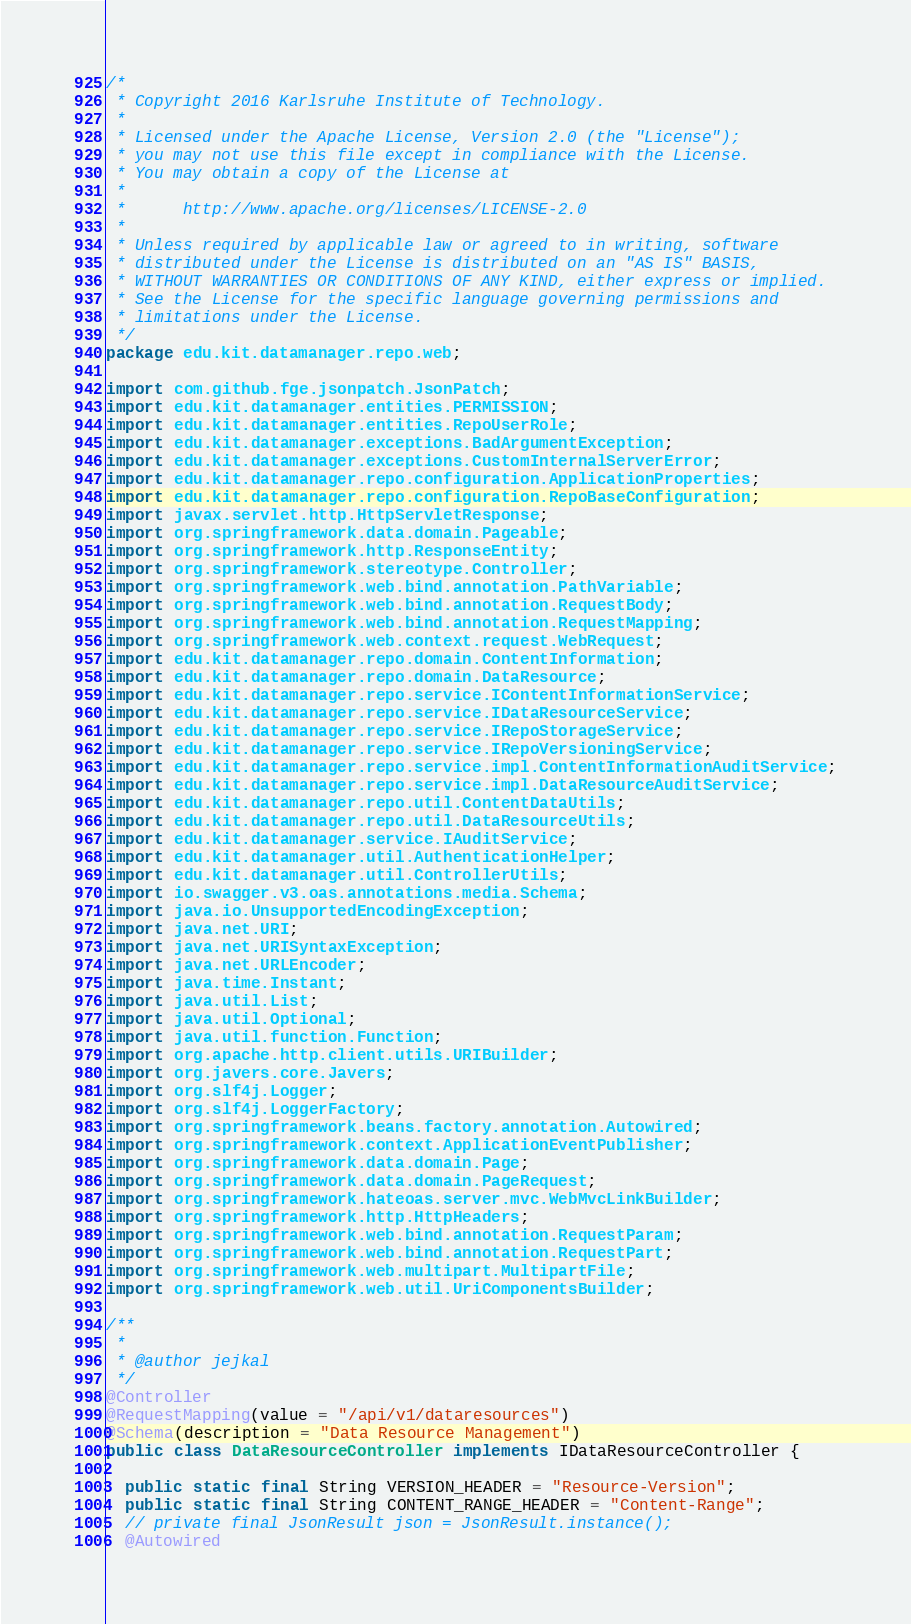Convert code to text. <code><loc_0><loc_0><loc_500><loc_500><_Java_>/*
 * Copyright 2016 Karlsruhe Institute of Technology.
 *
 * Licensed under the Apache License, Version 2.0 (the "License");
 * you may not use this file except in compliance with the License.
 * You may obtain a copy of the License at
 *
 *      http://www.apache.org/licenses/LICENSE-2.0
 *
 * Unless required by applicable law or agreed to in writing, software
 * distributed under the License is distributed on an "AS IS" BASIS,
 * WITHOUT WARRANTIES OR CONDITIONS OF ANY KIND, either express or implied.
 * See the License for the specific language governing permissions and
 * limitations under the License.
 */
package edu.kit.datamanager.repo.web;

import com.github.fge.jsonpatch.JsonPatch;
import edu.kit.datamanager.entities.PERMISSION;
import edu.kit.datamanager.entities.RepoUserRole;
import edu.kit.datamanager.exceptions.BadArgumentException;
import edu.kit.datamanager.exceptions.CustomInternalServerError;
import edu.kit.datamanager.repo.configuration.ApplicationProperties;
import edu.kit.datamanager.repo.configuration.RepoBaseConfiguration;
import javax.servlet.http.HttpServletResponse;
import org.springframework.data.domain.Pageable;
import org.springframework.http.ResponseEntity;
import org.springframework.stereotype.Controller;
import org.springframework.web.bind.annotation.PathVariable;
import org.springframework.web.bind.annotation.RequestBody;
import org.springframework.web.bind.annotation.RequestMapping;
import org.springframework.web.context.request.WebRequest;
import edu.kit.datamanager.repo.domain.ContentInformation;
import edu.kit.datamanager.repo.domain.DataResource;
import edu.kit.datamanager.repo.service.IContentInformationService;
import edu.kit.datamanager.repo.service.IDataResourceService;
import edu.kit.datamanager.repo.service.IRepoStorageService;
import edu.kit.datamanager.repo.service.IRepoVersioningService;
import edu.kit.datamanager.repo.service.impl.ContentInformationAuditService;
import edu.kit.datamanager.repo.service.impl.DataResourceAuditService;
import edu.kit.datamanager.repo.util.ContentDataUtils;
import edu.kit.datamanager.repo.util.DataResourceUtils;
import edu.kit.datamanager.service.IAuditService;
import edu.kit.datamanager.util.AuthenticationHelper;
import edu.kit.datamanager.util.ControllerUtils;
import io.swagger.v3.oas.annotations.media.Schema;
import java.io.UnsupportedEncodingException;
import java.net.URI;
import java.net.URISyntaxException;
import java.net.URLEncoder;
import java.time.Instant;
import java.util.List;
import java.util.Optional;
import java.util.function.Function;
import org.apache.http.client.utils.URIBuilder;
import org.javers.core.Javers;
import org.slf4j.Logger;
import org.slf4j.LoggerFactory;
import org.springframework.beans.factory.annotation.Autowired;
import org.springframework.context.ApplicationEventPublisher;
import org.springframework.data.domain.Page;
import org.springframework.data.domain.PageRequest;
import org.springframework.hateoas.server.mvc.WebMvcLinkBuilder;
import org.springframework.http.HttpHeaders;
import org.springframework.web.bind.annotation.RequestParam;
import org.springframework.web.bind.annotation.RequestPart;
import org.springframework.web.multipart.MultipartFile;
import org.springframework.web.util.UriComponentsBuilder;

/**
 *
 * @author jejkal
 */
@Controller
@RequestMapping(value = "/api/v1/dataresources")
@Schema(description = "Data Resource Management")
public class DataResourceController implements IDataResourceController {

  public static final String VERSION_HEADER = "Resource-Version";
  public static final String CONTENT_RANGE_HEADER = "Content-Range";
  // private final JsonResult json = JsonResult.instance();
  @Autowired</code> 